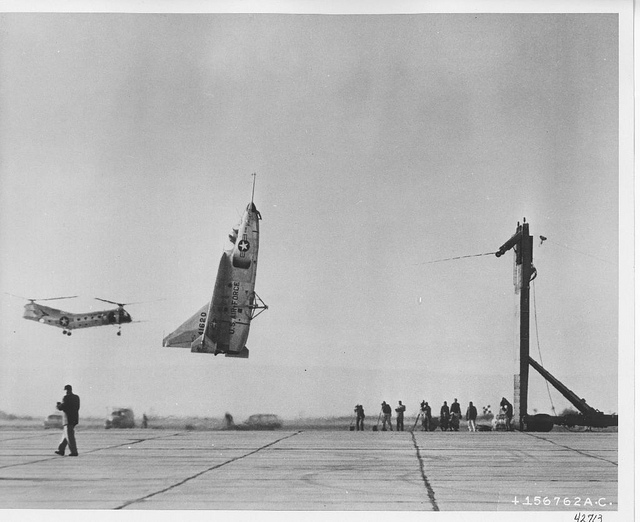Identify and read out the text in this image. 156762A.C. 